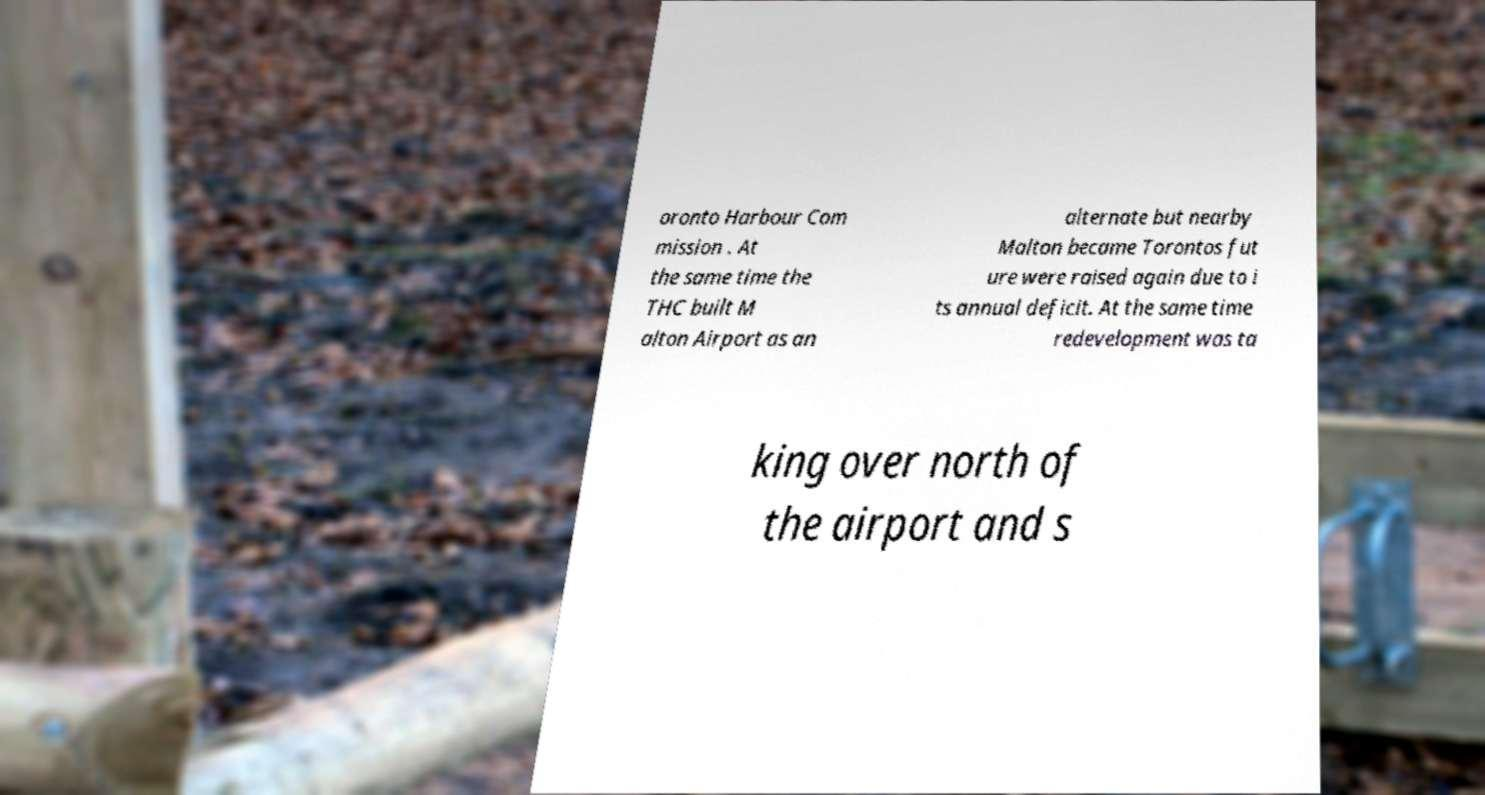Could you extract and type out the text from this image? oronto Harbour Com mission . At the same time the THC built M alton Airport as an alternate but nearby Malton became Torontos fut ure were raised again due to i ts annual deficit. At the same time redevelopment was ta king over north of the airport and s 